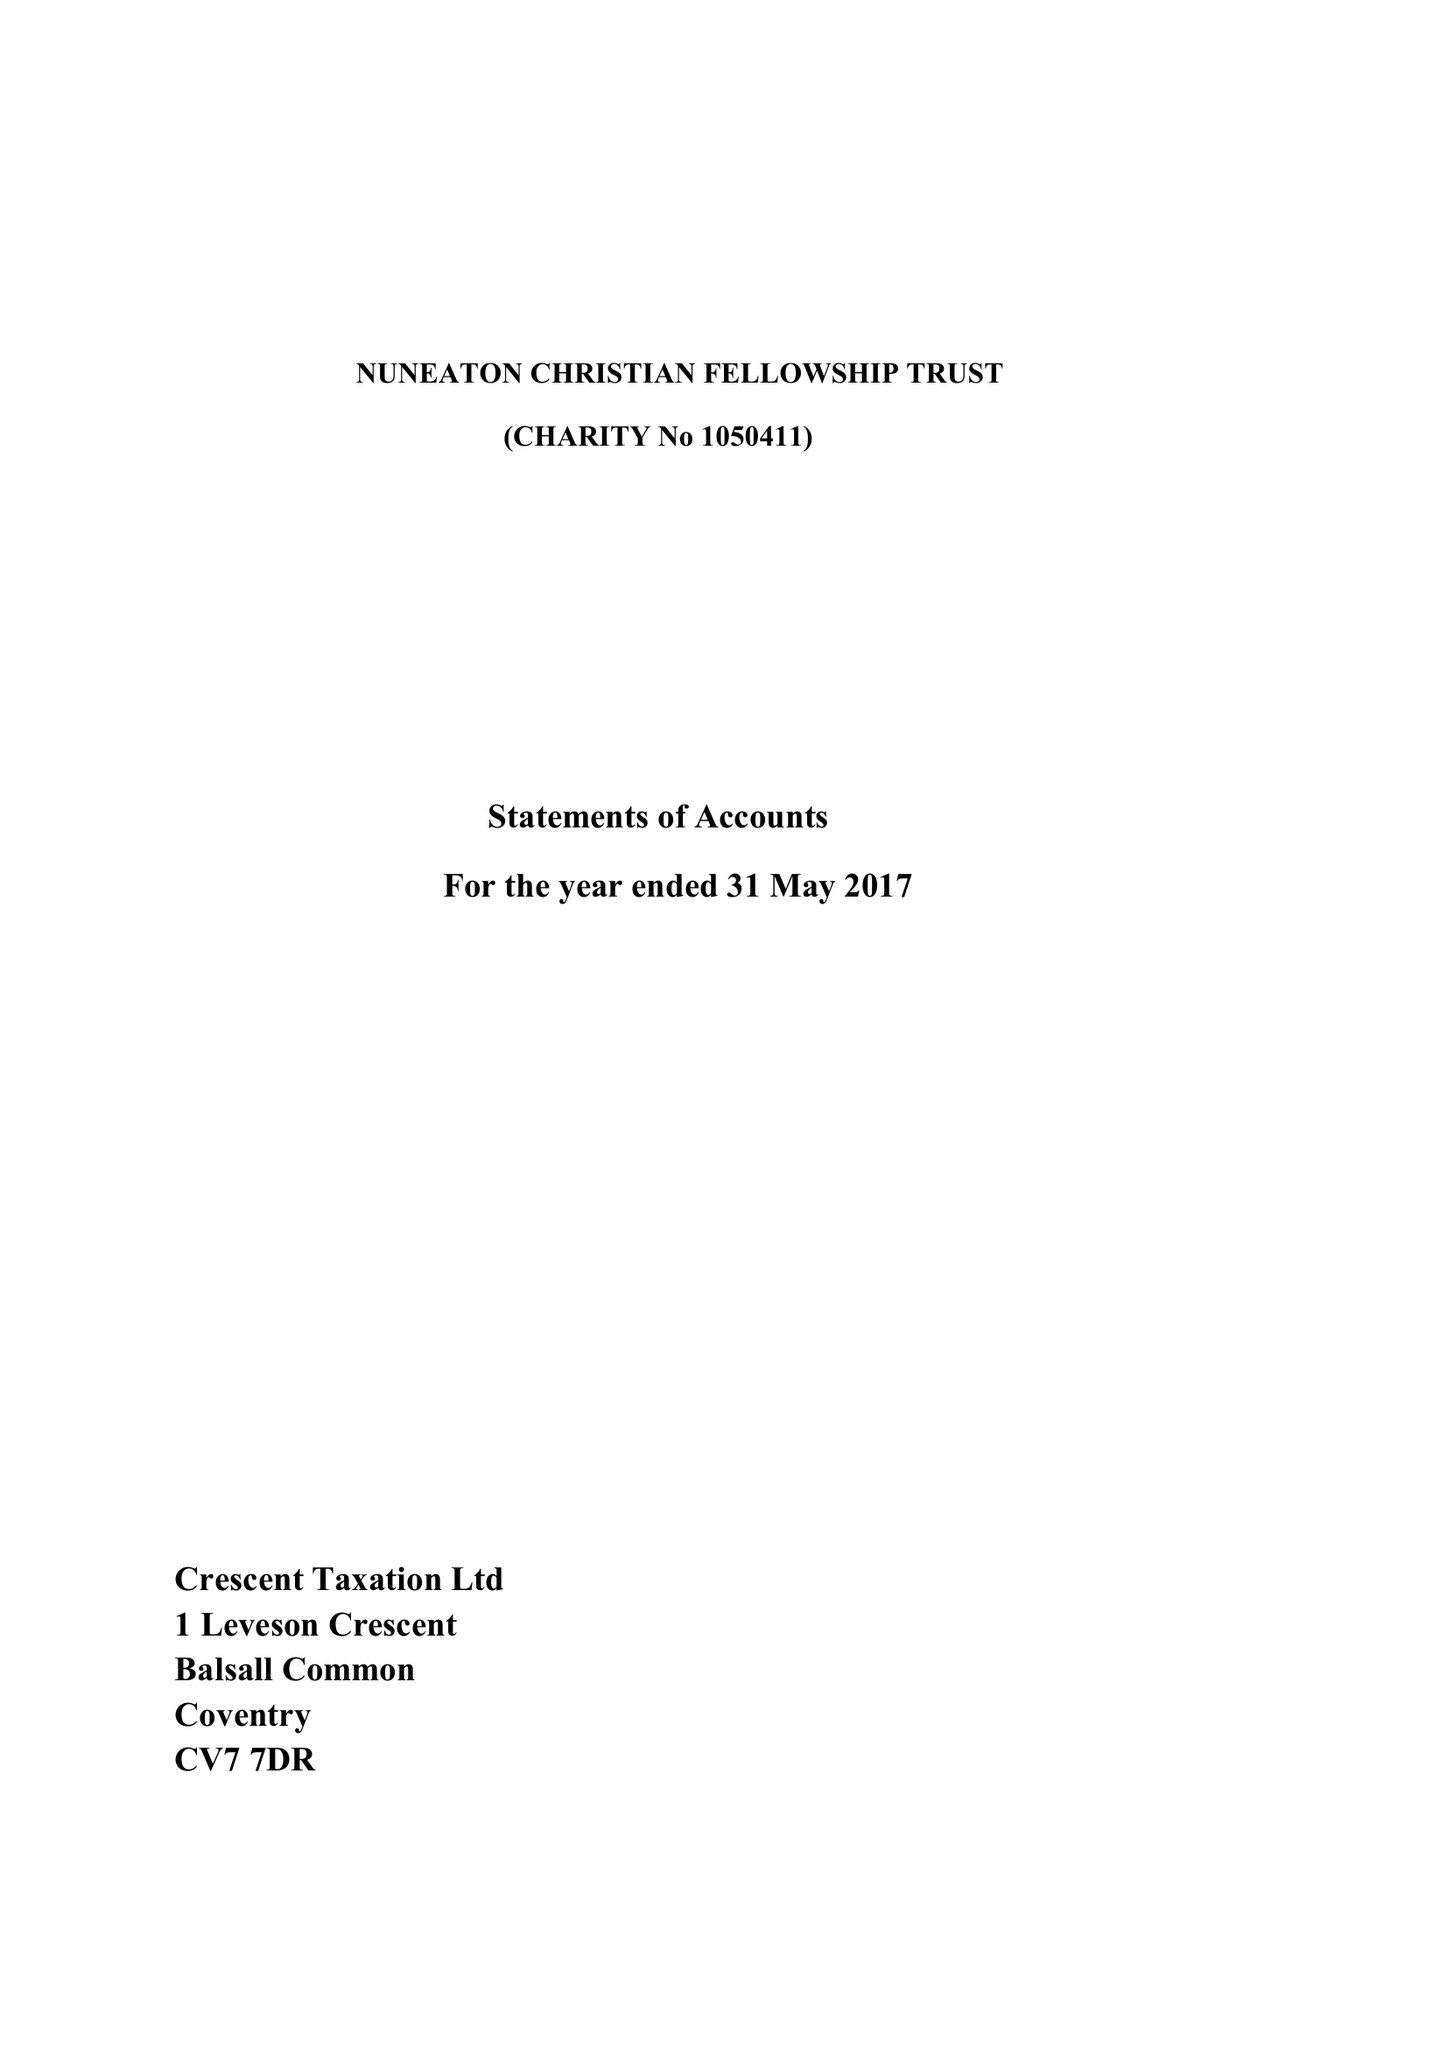What is the value for the address__postcode?
Answer the question using a single word or phrase. CV11 6LT 